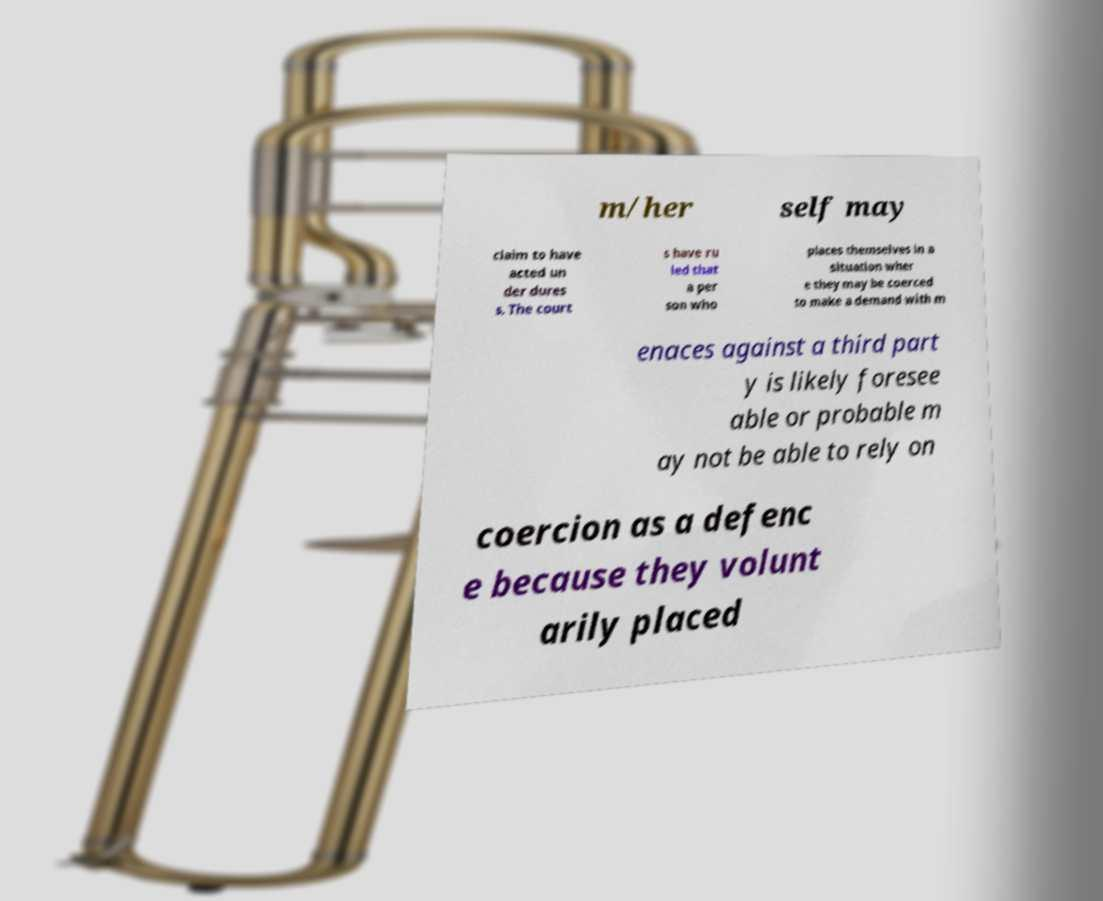I need the written content from this picture converted into text. Can you do that? m/her self may claim to have acted un der dures s. The court s have ru led that a per son who places themselves in a situation wher e they may be coerced to make a demand with m enaces against a third part y is likely foresee able or probable m ay not be able to rely on coercion as a defenc e because they volunt arily placed 